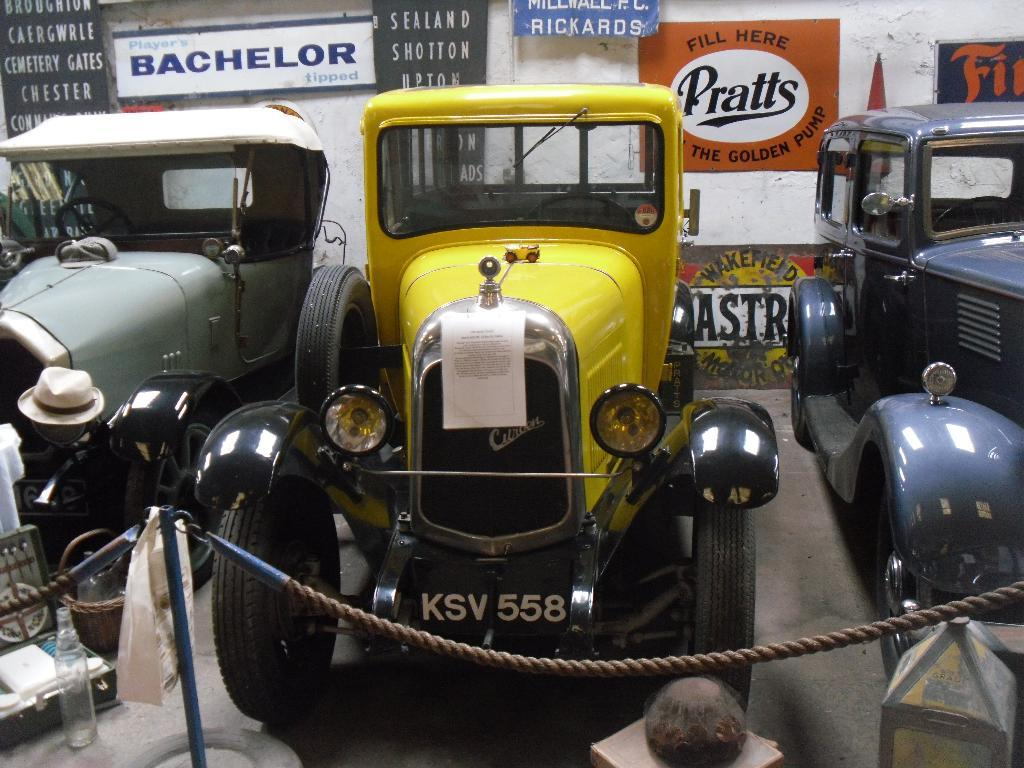What can be seen on the ground in the image? There are vehicles on the ground in the image. What is visible in the background of the image? There are posters and a wall visible in the background of the image. What decision was made by the protestors on the sidewalk in the image? There is no protest or sidewalk present in the image; it only features vehicles on the ground and posters and a wall in the background. 